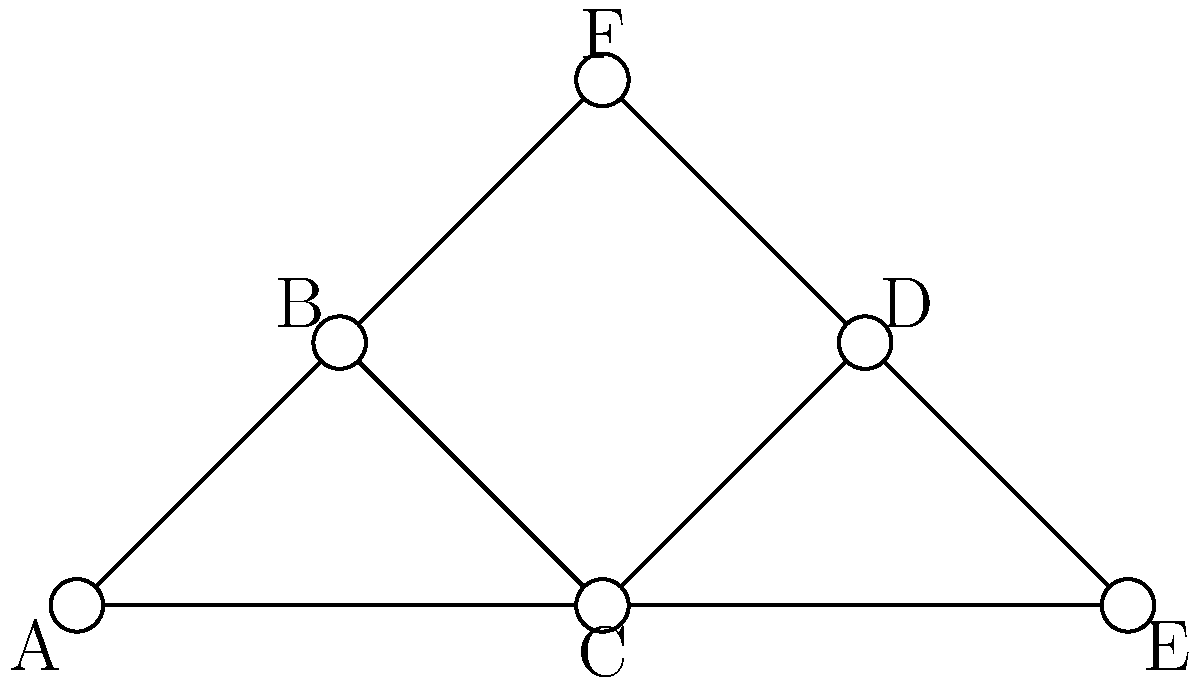In this social network of Humboldt County cannabis cultivators, each node represents a cultivator and each edge represents a direct working relationship. Which cultivator has the highest degree centrality, making them potentially the most influential in the community? To determine the cultivator with the highest degree centrality, we need to count the number of direct connections (edges) each cultivator (node) has:

1. Cultivator A: 2 connections (B and C)
2. Cultivator B: 3 connections (A, C, and F)
3. Cultivator C: 4 connections (A, B, D, and E)
4. Cultivator D: 3 connections (C, E, and F)
5. Cultivator E: 2 connections (C and D)
6. Cultivator F: 2 connections (B and D)

Cultivator C has the highest number of direct connections with 4 edges, giving it the highest degree centrality in this network.

In the context of cannabis cultivation in Humboldt County, this could mean that Cultivator C has the most diverse range of working relationships, potentially involving different aspects of the cultivation process such as seed sourcing, growing techniques, or distribution channels. This position in the network suggests that Cultivator C might be a key player in information sharing and collaboration within the local cannabis community.
Answer: Cultivator C 